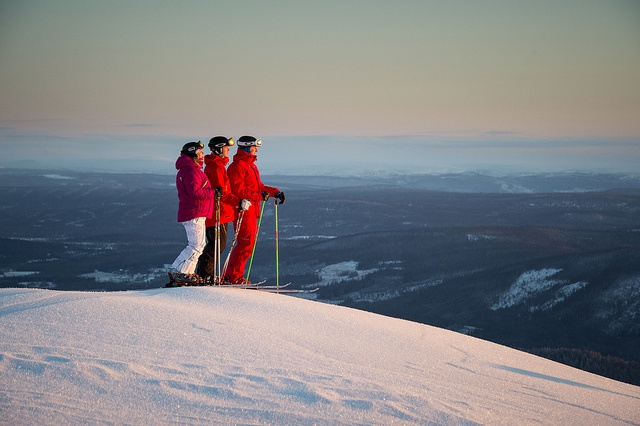Describe the objects in this image and their specific colors. I can see people in gray, purple, black, darkgray, and brown tones, people in gray, maroon, red, and black tones, people in gray, black, maroon, and red tones, and skis in gray, darkgray, and pink tones in this image. 